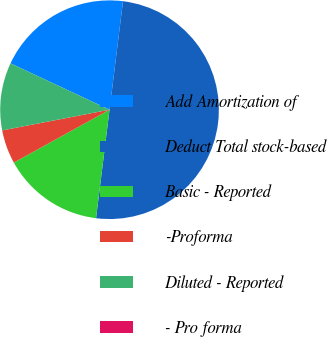Convert chart to OTSL. <chart><loc_0><loc_0><loc_500><loc_500><pie_chart><fcel>Add Amortization of<fcel>Deduct Total stock-based<fcel>Basic - Reported<fcel>-Proforma<fcel>Diluted - Reported<fcel>- Pro forma<nl><fcel>20.0%<fcel>50.0%<fcel>15.0%<fcel>5.0%<fcel>10.0%<fcel>0.0%<nl></chart> 